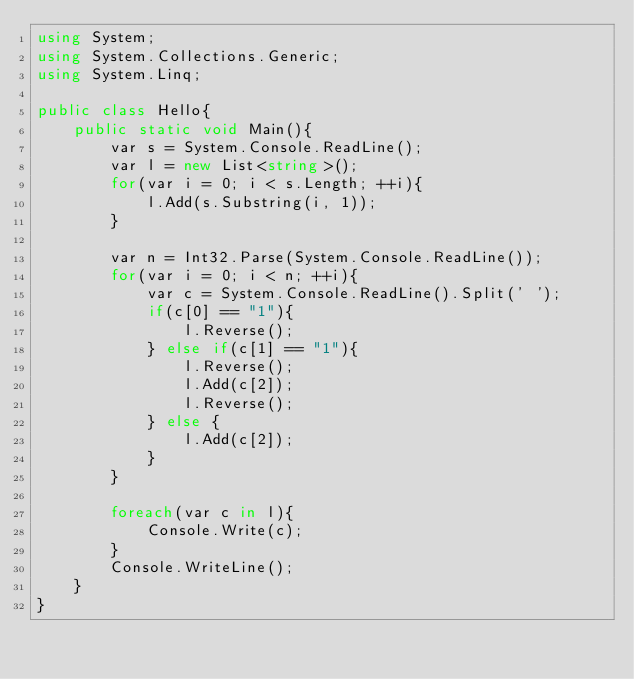<code> <loc_0><loc_0><loc_500><loc_500><_C#_>using System;
using System.Collections.Generic;
using System.Linq;

public class Hello{
    public static void Main(){
        var s = System.Console.ReadLine();
        var l = new List<string>();
        for(var i = 0; i < s.Length; ++i){
            l.Add(s.Substring(i, 1));
        }
        
        var n = Int32.Parse(System.Console.ReadLine());
        for(var i = 0; i < n; ++i){
            var c = System.Console.ReadLine().Split(' ');
            if(c[0] == "1"){
                l.Reverse();
            } else if(c[1] == "1"){
                l.Reverse();
                l.Add(c[2]);
                l.Reverse();
            } else {
                l.Add(c[2]);
            }
        }

        foreach(var c in l){
            Console.Write(c);
        }
        Console.WriteLine();
    }
}
</code> 